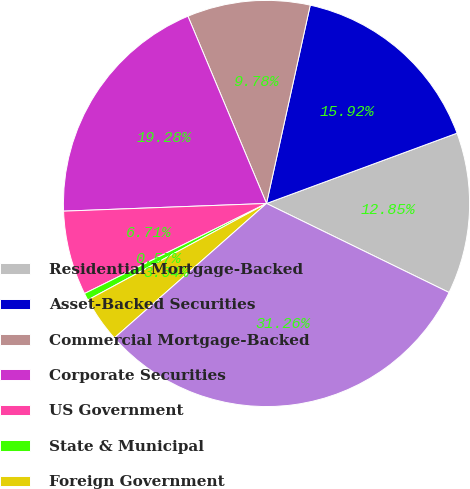<chart> <loc_0><loc_0><loc_500><loc_500><pie_chart><fcel>Residential Mortgage-Backed<fcel>Asset-Backed Securities<fcel>Commercial Mortgage-Backed<fcel>Corporate Securities<fcel>US Government<fcel>State & Municipal<fcel>Foreign Government<fcel>Total<nl><fcel>12.85%<fcel>15.92%<fcel>9.78%<fcel>19.28%<fcel>6.71%<fcel>0.57%<fcel>3.64%<fcel>31.26%<nl></chart> 